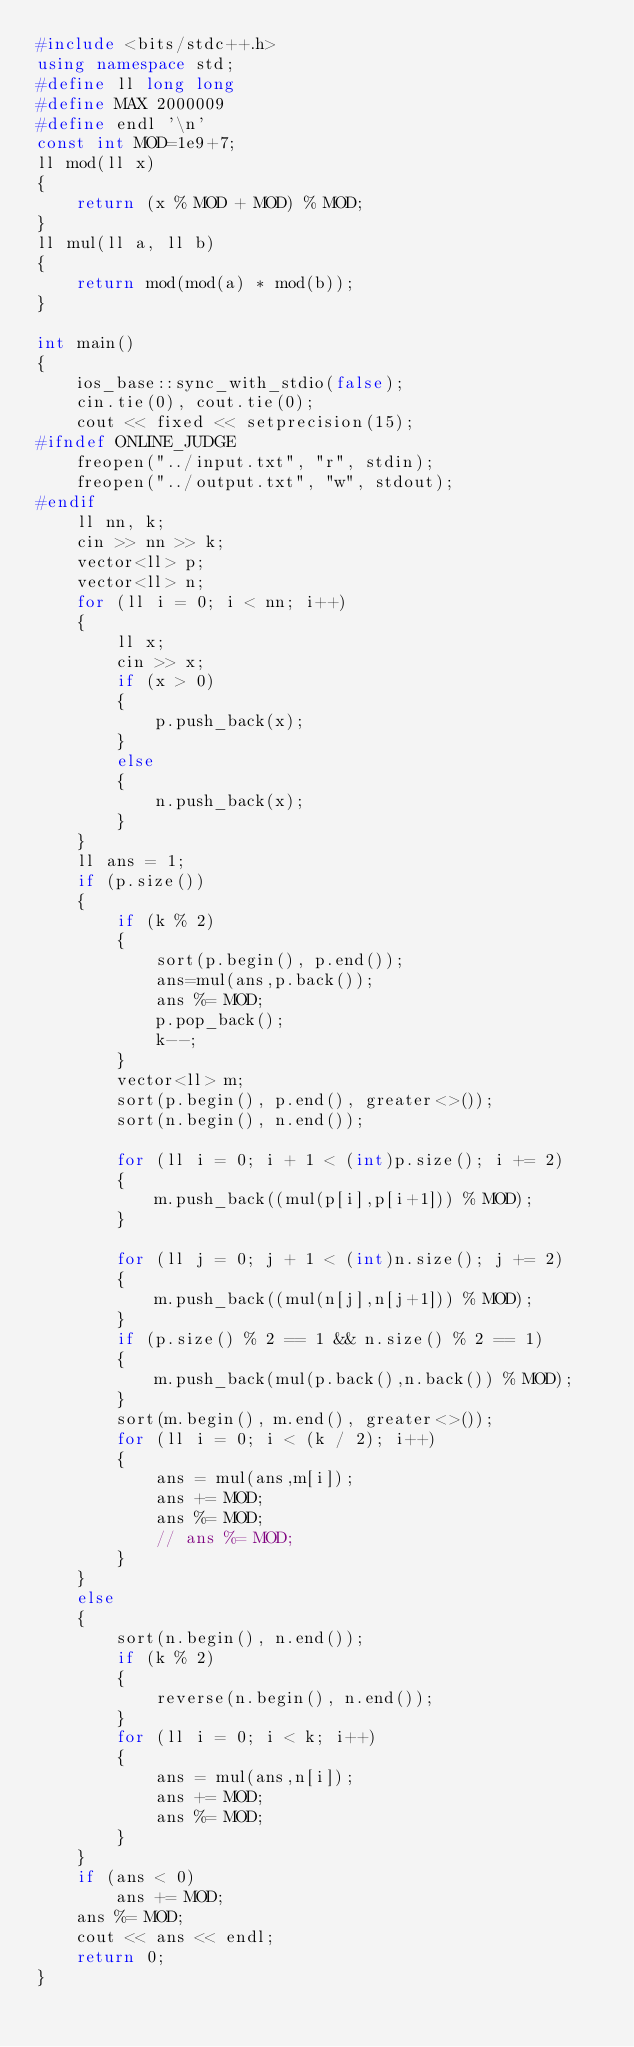<code> <loc_0><loc_0><loc_500><loc_500><_C++_>#include <bits/stdc++.h>
using namespace std;
#define ll long long
#define MAX 2000009
#define endl '\n'
const int MOD=1e9+7;
ll mod(ll x)
{
    return (x % MOD + MOD) % MOD;
}
ll mul(ll a, ll b)
{
    return mod(mod(a) * mod(b));
}

int main()
{
    ios_base::sync_with_stdio(false);
    cin.tie(0), cout.tie(0);
    cout << fixed << setprecision(15);
#ifndef ONLINE_JUDGE
    freopen("../input.txt", "r", stdin);
    freopen("../output.txt", "w", stdout);
#endif
    ll nn, k;
    cin >> nn >> k;
    vector<ll> p;
    vector<ll> n;
    for (ll i = 0; i < nn; i++)
    {
        ll x;
        cin >> x;
        if (x > 0)
        {
            p.push_back(x);
        }
        else
        {
            n.push_back(x);
        }
    }
    ll ans = 1;
    if (p.size())
    {
        if (k % 2)
        {
            sort(p.begin(), p.end());
            ans=mul(ans,p.back());
            ans %= MOD;
            p.pop_back();
            k--;
        }
        vector<ll> m;
        sort(p.begin(), p.end(), greater<>());
        sort(n.begin(), n.end());

        for (ll i = 0; i + 1 < (int)p.size(); i += 2)
        {
            m.push_back((mul(p[i],p[i+1])) % MOD);
        }

        for (ll j = 0; j + 1 < (int)n.size(); j += 2)
        {
            m.push_back((mul(n[j],n[j+1])) % MOD);
        }
        if (p.size() % 2 == 1 && n.size() % 2 == 1)
        {
            m.push_back(mul(p.back(),n.back()) % MOD);
        }
        sort(m.begin(), m.end(), greater<>());
        for (ll i = 0; i < (k / 2); i++)
        {
            ans = mul(ans,m[i]);
            ans += MOD;
            ans %= MOD;
            // ans %= MOD;
        }
    }
    else
    {
        sort(n.begin(), n.end());
        if (k % 2)
        {
            reverse(n.begin(), n.end());
        }
        for (ll i = 0; i < k; i++)
        {
            ans = mul(ans,n[i]);
            ans += MOD;
            ans %= MOD;
        }
    }
    if (ans < 0)
        ans += MOD;
    ans %= MOD;
    cout << ans << endl;
    return 0;
}</code> 